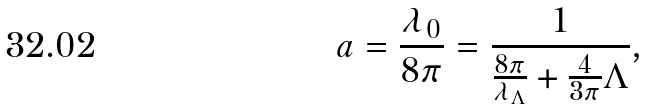Convert formula to latex. <formula><loc_0><loc_0><loc_500><loc_500>a = \frac { \lambda _ { 0 } } { 8 \pi } = \frac { 1 } { \frac { 8 \pi } { \lambda _ { \Lambda } } + \frac { 4 } { 3 \pi } \Lambda } ,</formula> 